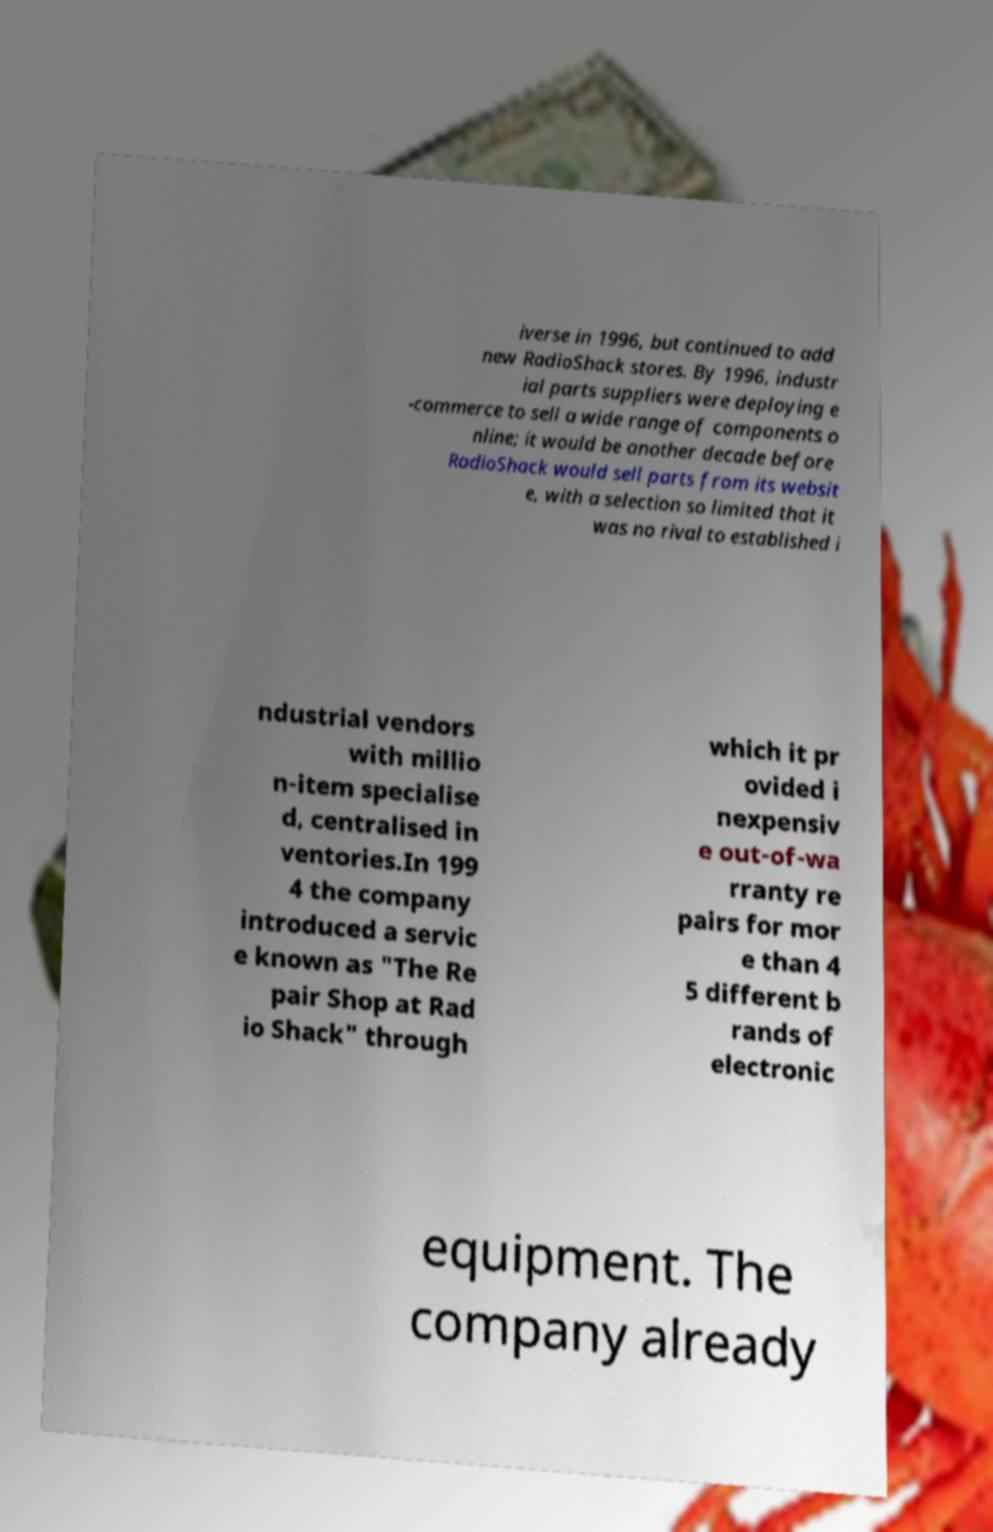Please identify and transcribe the text found in this image. iverse in 1996, but continued to add new RadioShack stores. By 1996, industr ial parts suppliers were deploying e -commerce to sell a wide range of components o nline; it would be another decade before RadioShack would sell parts from its websit e, with a selection so limited that it was no rival to established i ndustrial vendors with millio n-item specialise d, centralised in ventories.In 199 4 the company introduced a servic e known as "The Re pair Shop at Rad io Shack" through which it pr ovided i nexpensiv e out-of-wa rranty re pairs for mor e than 4 5 different b rands of electronic equipment. The company already 